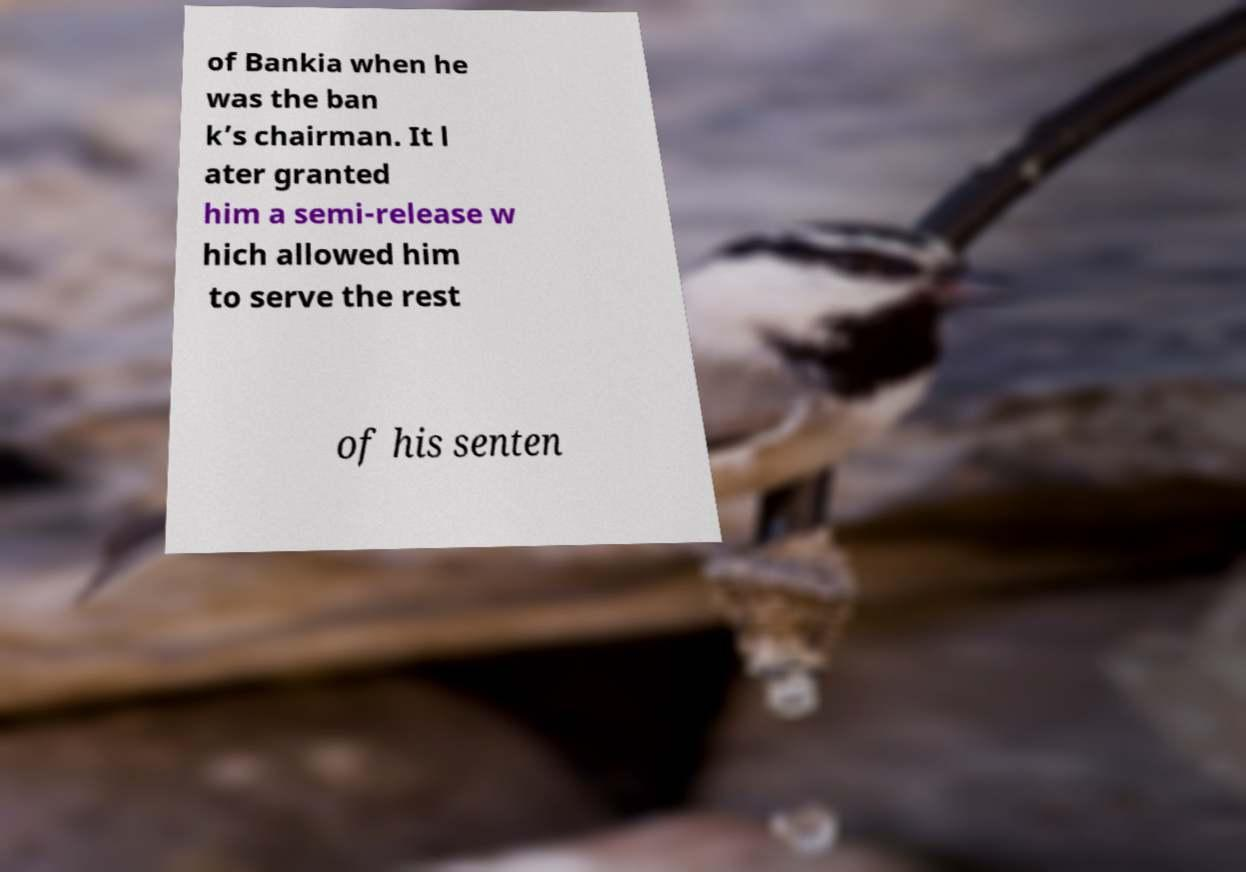For documentation purposes, I need the text within this image transcribed. Could you provide that? of Bankia when he was the ban k’s chairman. It l ater granted him a semi-release w hich allowed him to serve the rest of his senten 